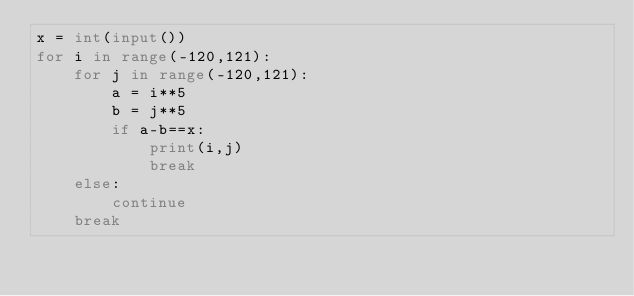<code> <loc_0><loc_0><loc_500><loc_500><_Python_>x = int(input())
for i in range(-120,121):
    for j in range(-120,121):
        a = i**5
        b = j**5
        if a-b==x:
            print(i,j)
            break
    else:
        continue
    break</code> 